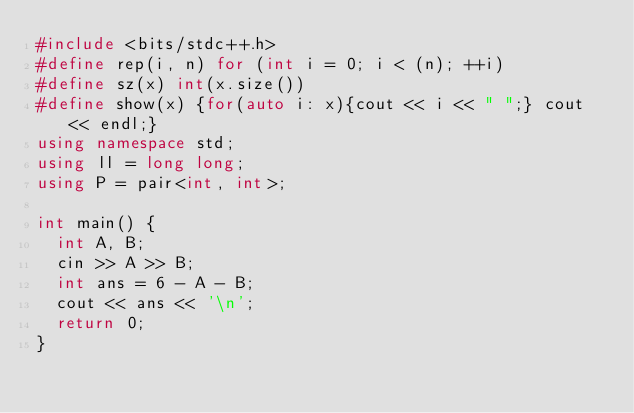<code> <loc_0><loc_0><loc_500><loc_500><_C++_>#include <bits/stdc++.h>
#define rep(i, n) for (int i = 0; i < (n); ++i)
#define sz(x) int(x.size())
#define show(x) {for(auto i: x){cout << i << " ";} cout << endl;}
using namespace std;
using ll = long long;
using P = pair<int, int>;

int main() {
  int A, B;
  cin >> A >> B;
  int ans = 6 - A - B;
  cout << ans << '\n';  
  return 0;
}</code> 